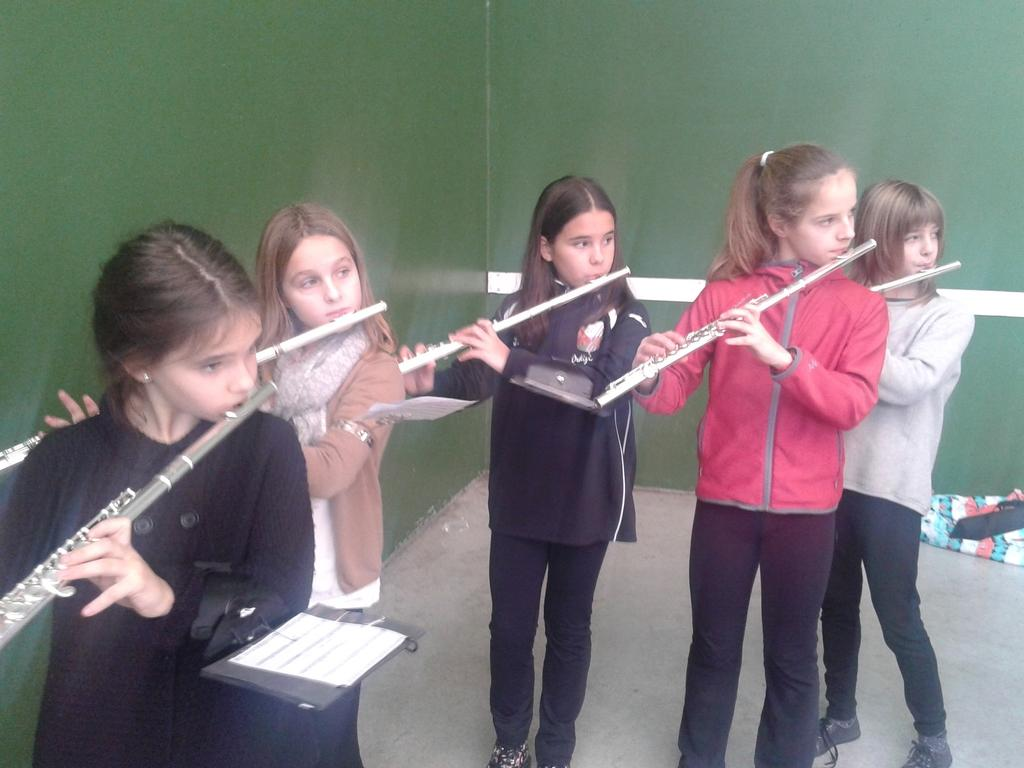How many people are in the image? There are 5 girls in the image. What are the girls holding in the image? Each girl is holding a flute. What can be seen in the background of the image? There is a wall in the background of the image. Is there a door visible in the image? No, there is no door present in the image. How many sons can be seen in the image? There are no sons present in the image; it features 5 girls. 